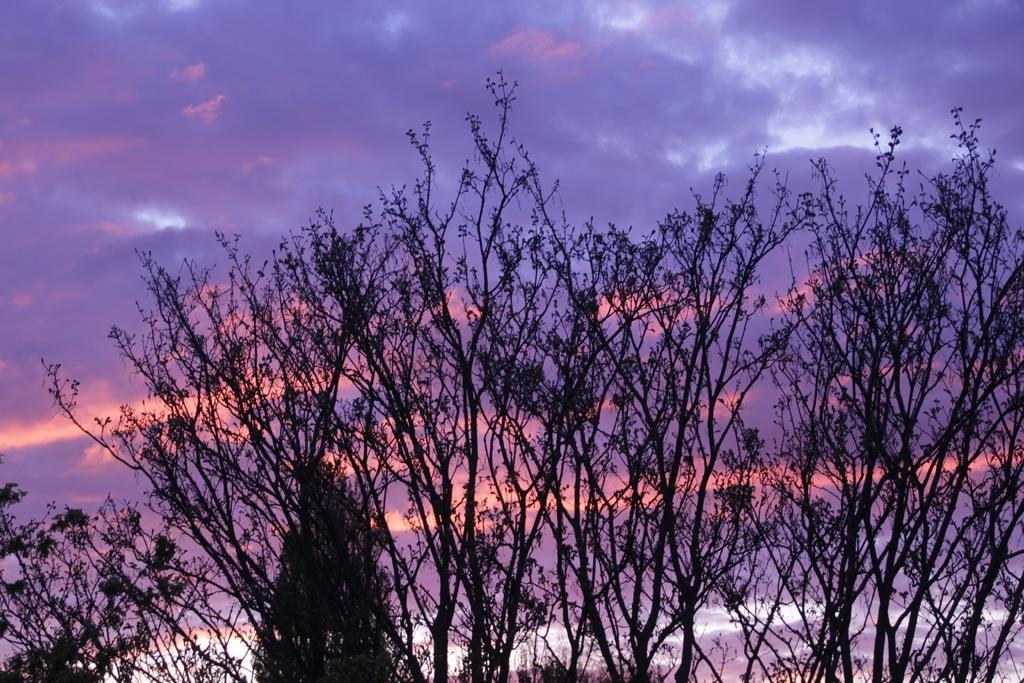How would you summarize this image in a sentence or two? In this image there are so many trees and some clouds in sky. 